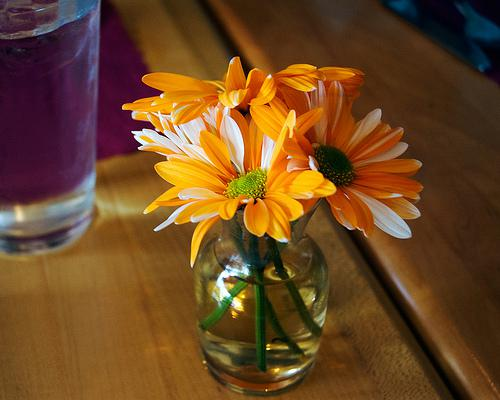Question: what color are the flowers?
Choices:
A. Red.
B. Green.
C. Orange.
D. Blue.
Answer with the letter. Answer: C Question: what is the the vase?
Choices:
A. Pinecones.
B. Branches.
C. Flowers.
D. Potpourri.
Answer with the letter. Answer: C Question: how many flowers are there?
Choices:
A. 4.
B. 1.
C. 2.
D. 3.
Answer with the letter. Answer: A Question: when the flowers are in the vase, what is in with them?
Choices:
A. Juice.
B. Water.
C. Milk.
D. Coffee.
Answer with the letter. Answer: B Question: why is there water in the vase?
Choices:
A. For the flowers.
B. To clean it.
C. To look nice.
D. To drink.
Answer with the letter. Answer: A 